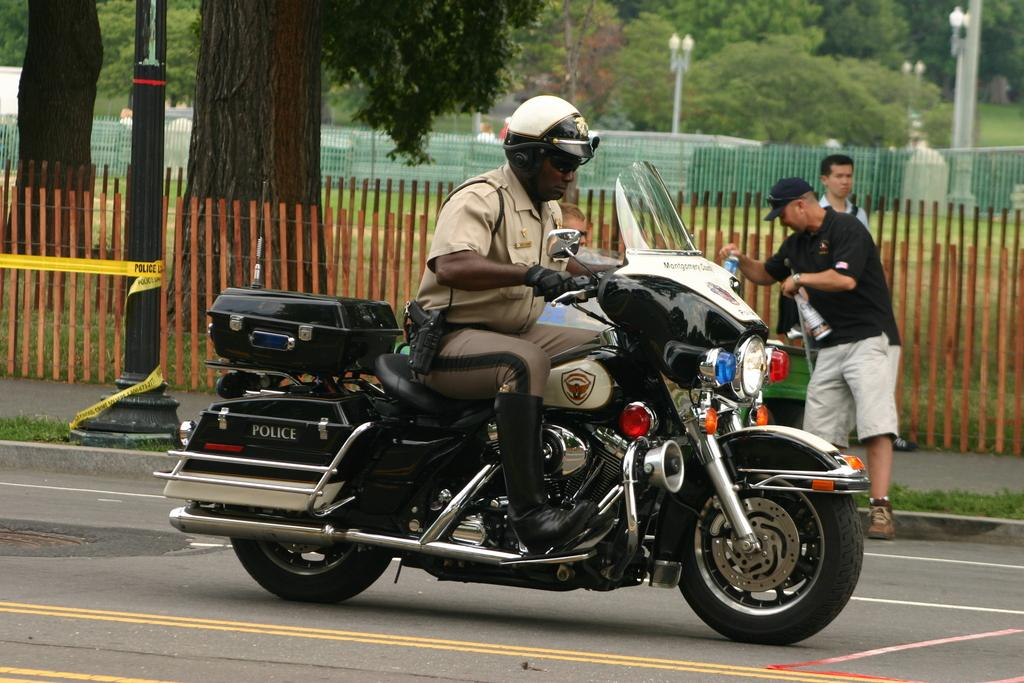Who is the main subject in the image? There is a man in the image. What is the man doing in the image? The man is riding a police bike. What type of wing is attached to the man's back in the image? There is no wing attached to the man's back in the image. How does the man feel about riding the police bike in the image? The image does not provide information about the man's feelings or emotions. 